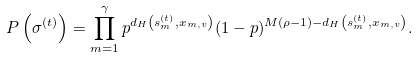Convert formula to latex. <formula><loc_0><loc_0><loc_500><loc_500>P \left ( \sigma ^ { ( t ) } \right ) = \prod _ { m = 1 } ^ { \gamma } p ^ { d _ { H } \left ( { s } _ { m } ^ { ( t ) } , { x } _ { m , v } \right ) } ( 1 - p ) ^ { M ( \rho - 1 ) - d _ { H } \left ( { s } _ { m } ^ { ( t ) } , { x } _ { m , v } \right ) } .</formula> 